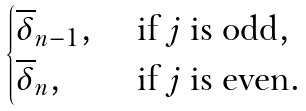Convert formula to latex. <formula><loc_0><loc_0><loc_500><loc_500>\begin{cases} \overline { \delta } _ { n - 1 } , & \text { if } j \text { is odd} , \\ \overline { \delta } _ { n } , & \text { if } j \text { is even} . \end{cases}</formula> 